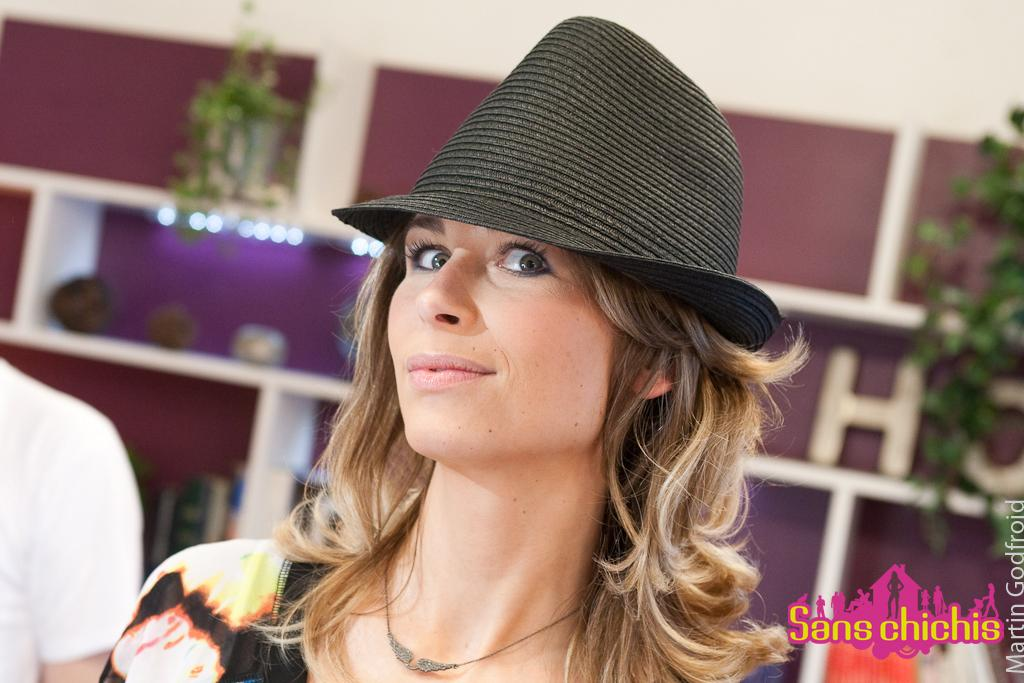What can be seen in the image? There is a person in the image. Can you describe the person's attire? The person is wearing clothes and a hat. Is there any text visible in the image? Yes, there is text in the bottom right of the image. What can be seen in the background of the image? There are wall shelves in the background of the image. What color is the paint on the stem of the plant in the image? There is no plant or stem present in the image. What kind of trouble is the person experiencing in the image? The image does not depict any trouble or difficulties being experienced by the person. 